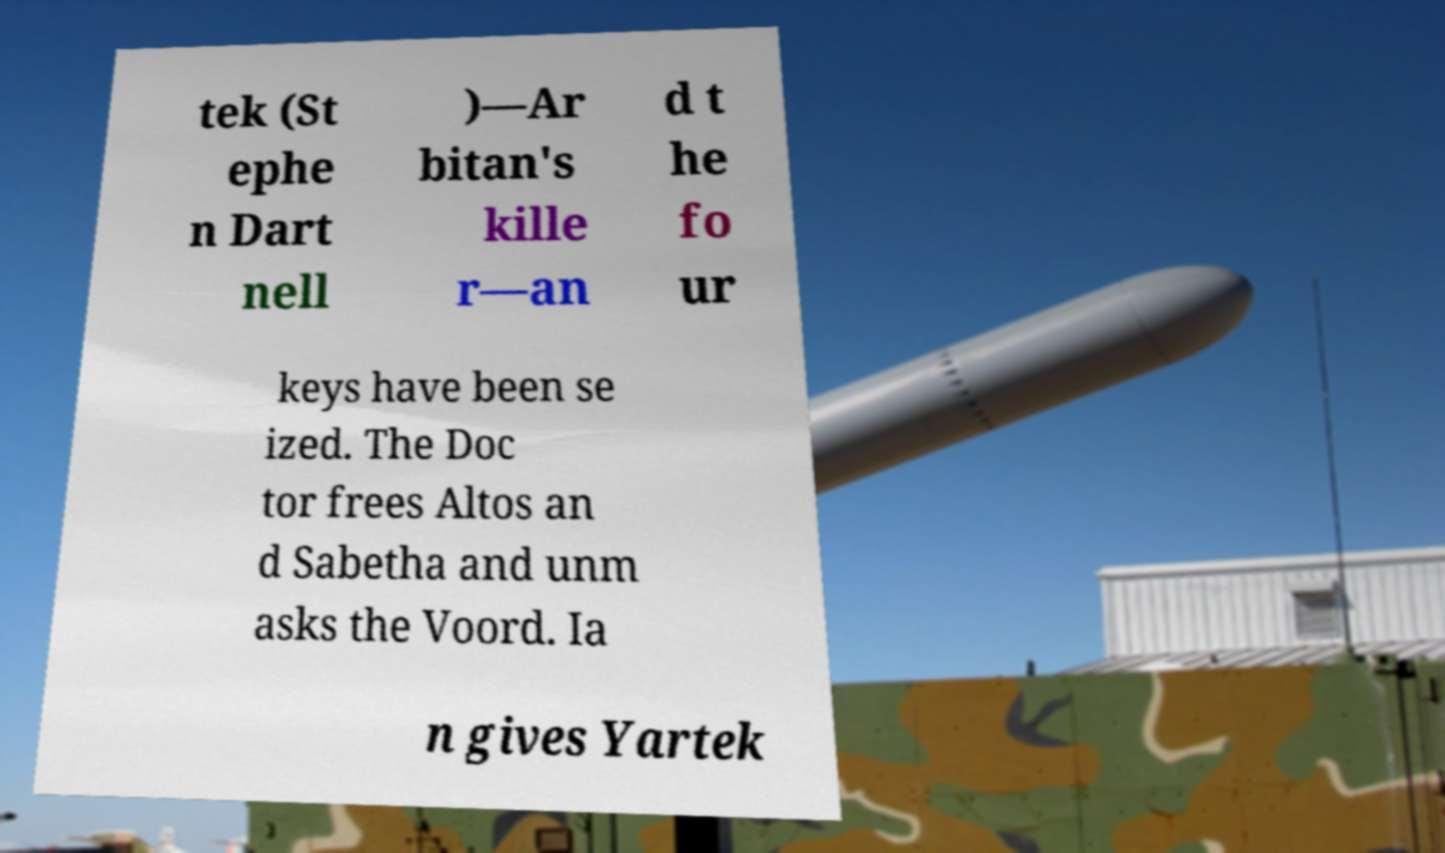Could you extract and type out the text from this image? tek (St ephe n Dart nell )—Ar bitan's kille r—an d t he fo ur keys have been se ized. The Doc tor frees Altos an d Sabetha and unm asks the Voord. Ia n gives Yartek 